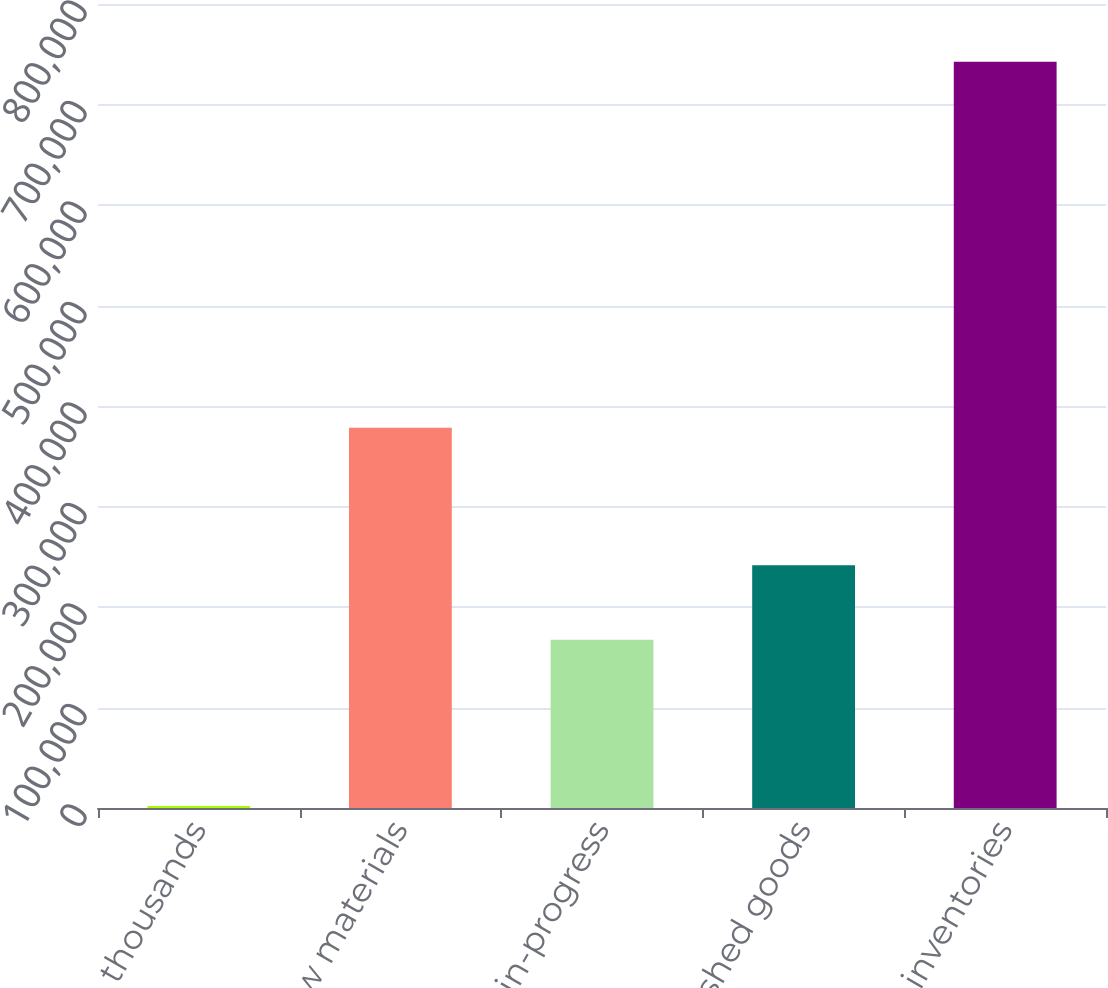<chart> <loc_0><loc_0><loc_500><loc_500><bar_chart><fcel>In thousands<fcel>Raw materials<fcel>Work-in-progress<fcel>Finished goods<fcel>Total inventories<nl><fcel>2017<fcel>378481<fcel>167390<fcel>241452<fcel>742634<nl></chart> 